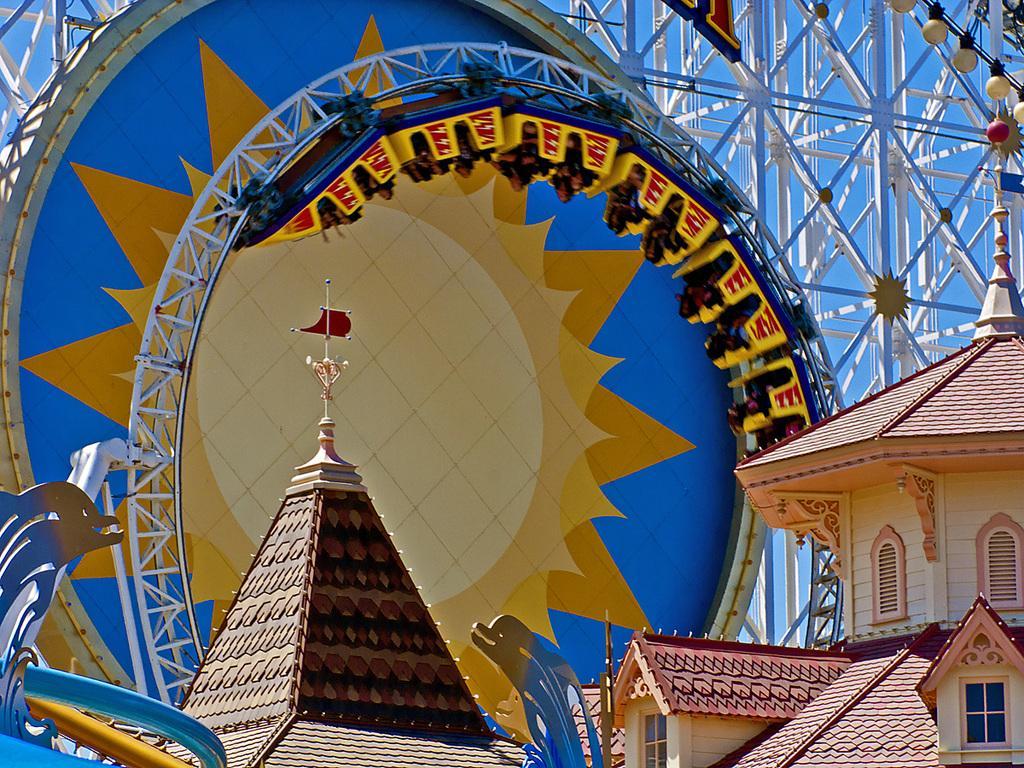Please provide a concise description of this image. In this image we can see a building, there is a window, at the back there is a roller coaster, and persons sitting in it, there is a dolphin sculpture on the left, there are lamps, there is a sky. 